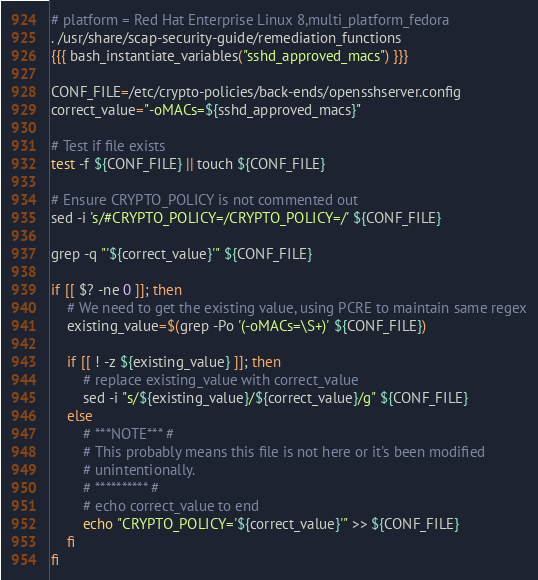<code> <loc_0><loc_0><loc_500><loc_500><_Bash_># platform = Red Hat Enterprise Linux 8,multi_platform_fedora
. /usr/share/scap-security-guide/remediation_functions
{{{ bash_instantiate_variables("sshd_approved_macs") }}}

CONF_FILE=/etc/crypto-policies/back-ends/opensshserver.config
correct_value="-oMACs=${sshd_approved_macs}"

# Test if file exists
test -f ${CONF_FILE} || touch ${CONF_FILE}

# Ensure CRYPTO_POLICY is not commented out
sed -i 's/#CRYPTO_POLICY=/CRYPTO_POLICY=/' ${CONF_FILE}

grep -q "'${correct_value}'" ${CONF_FILE}

if [[ $? -ne 0 ]]; then
    # We need to get the existing value, using PCRE to maintain same regex
    existing_value=$(grep -Po '(-oMACs=\S+)' ${CONF_FILE})

    if [[ ! -z ${existing_value} ]]; then
        # replace existing_value with correct_value
        sed -i "s/${existing_value}/${correct_value}/g" ${CONF_FILE}
    else
        # ***NOTE*** #
        # This probably means this file is not here or it's been modified
        # unintentionally.
        # ********** #
        # echo correct_value to end
        echo "CRYPTO_POLICY='${correct_value}'" >> ${CONF_FILE}
    fi
fi
</code> 